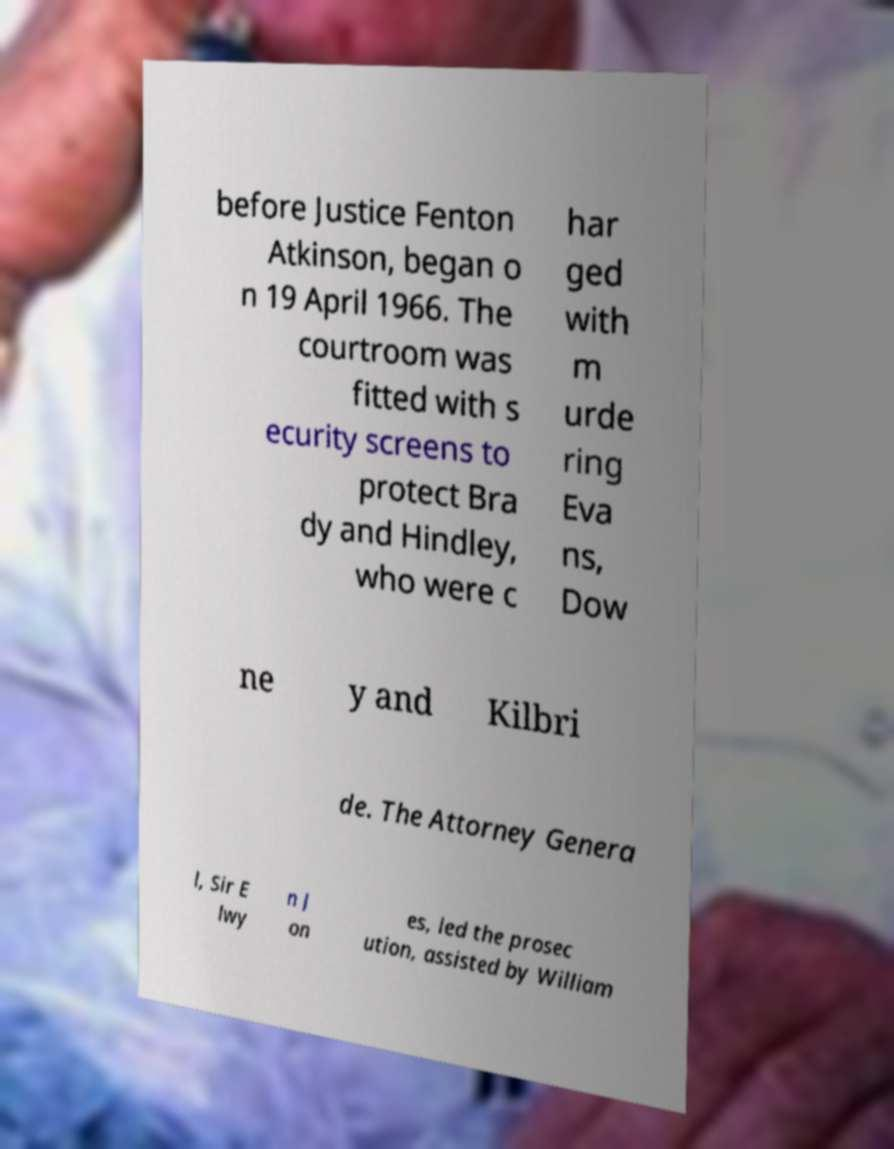Could you extract and type out the text from this image? before Justice Fenton Atkinson, began o n 19 April 1966. The courtroom was fitted with s ecurity screens to protect Bra dy and Hindley, who were c har ged with m urde ring Eva ns, Dow ne y and Kilbri de. The Attorney Genera l, Sir E lwy n J on es, led the prosec ution, assisted by William 